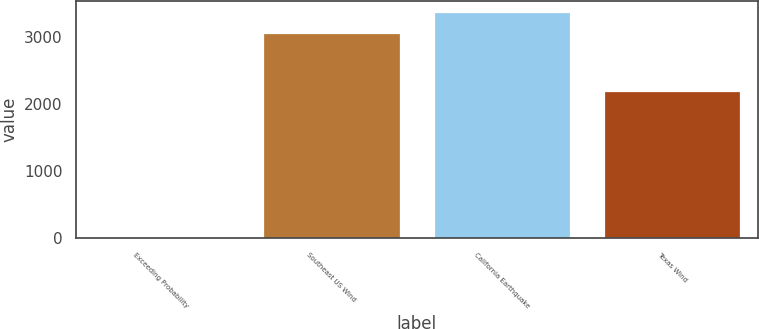<chart> <loc_0><loc_0><loc_500><loc_500><bar_chart><fcel>Exceeding Probability<fcel>Southeast US Wind<fcel>California Earthquake<fcel>Texas Wind<nl><fcel>0.1<fcel>3053<fcel>3372.09<fcel>2188<nl></chart> 